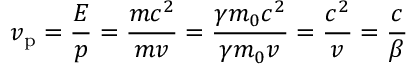<formula> <loc_0><loc_0><loc_500><loc_500>v _ { p } = { \frac { E } { p } } = { \frac { m c ^ { 2 } } { m v } } = { \frac { \gamma m _ { 0 } c ^ { 2 } } { \gamma m _ { 0 } v } } = { \frac { c ^ { 2 } } { v } } = { \frac { c } { \beta } }</formula> 